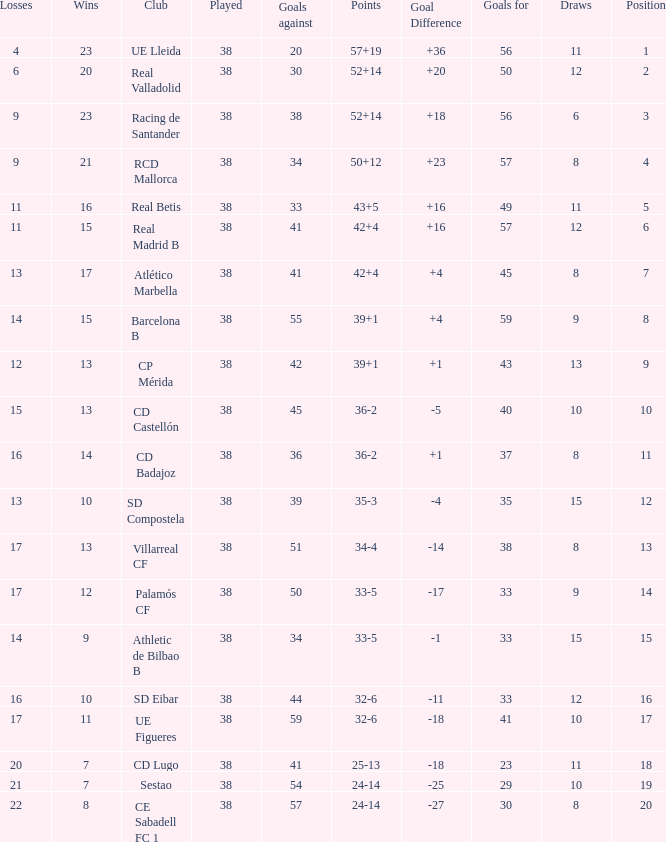What is the highest number played with a goal difference less than -27? None. Would you mind parsing the complete table? {'header': ['Losses', 'Wins', 'Club', 'Played', 'Goals against', 'Points', 'Goal Difference', 'Goals for', 'Draws', 'Position'], 'rows': [['4', '23', 'UE Lleida', '38', '20', '57+19', '+36', '56', '11', '1'], ['6', '20', 'Real Valladolid', '38', '30', '52+14', '+20', '50', '12', '2'], ['9', '23', 'Racing de Santander', '38', '38', '52+14', '+18', '56', '6', '3'], ['9', '21', 'RCD Mallorca', '38', '34', '50+12', '+23', '57', '8', '4'], ['11', '16', 'Real Betis', '38', '33', '43+5', '+16', '49', '11', '5'], ['11', '15', 'Real Madrid B', '38', '41', '42+4', '+16', '57', '12', '6'], ['13', '17', 'Atlético Marbella', '38', '41', '42+4', '+4', '45', '8', '7'], ['14', '15', 'Barcelona B', '38', '55', '39+1', '+4', '59', '9', '8'], ['12', '13', 'CP Mérida', '38', '42', '39+1', '+1', '43', '13', '9'], ['15', '13', 'CD Castellón', '38', '45', '36-2', '-5', '40', '10', '10'], ['16', '14', 'CD Badajoz', '38', '36', '36-2', '+1', '37', '8', '11'], ['13', '10', 'SD Compostela', '38', '39', '35-3', '-4', '35', '15', '12'], ['17', '13', 'Villarreal CF', '38', '51', '34-4', '-14', '38', '8', '13'], ['17', '12', 'Palamós CF', '38', '50', '33-5', '-17', '33', '9', '14'], ['14', '9', 'Athletic de Bilbao B', '38', '34', '33-5', '-1', '33', '15', '15'], ['16', '10', 'SD Eibar', '38', '44', '32-6', '-11', '33', '12', '16'], ['17', '11', 'UE Figueres', '38', '59', '32-6', '-18', '41', '10', '17'], ['20', '7', 'CD Lugo', '38', '41', '25-13', '-18', '23', '11', '18'], ['21', '7', 'Sestao', '38', '54', '24-14', '-25', '29', '10', '19'], ['22', '8', 'CE Sabadell FC 1', '38', '57', '24-14', '-27', '30', '8', '20']]} 